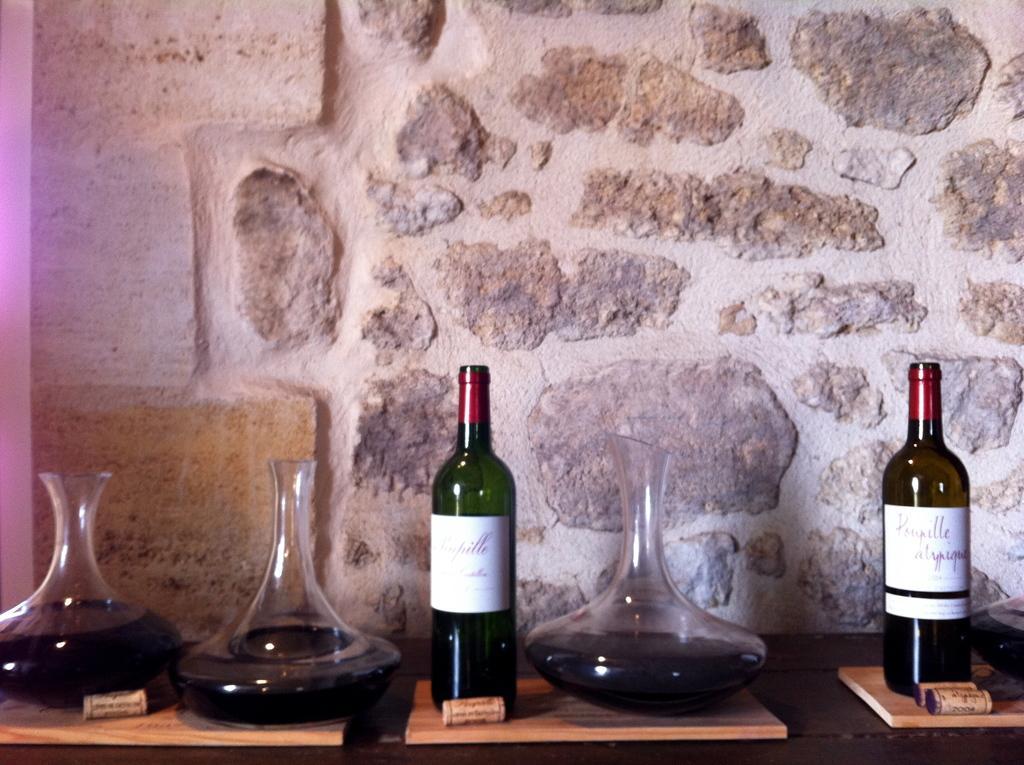Can you describe this image briefly? In this image i can see 2 wine bottles and few jars. In the background i can see a wall. 